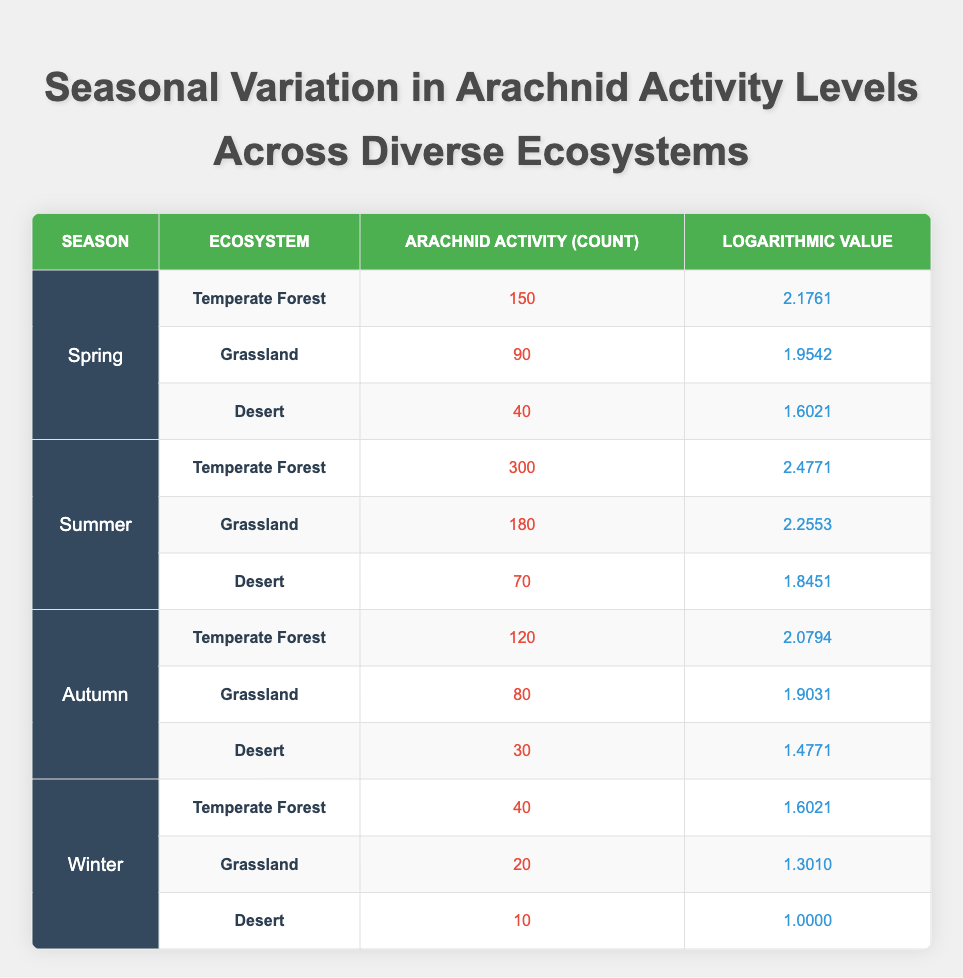What is the arachnid activity count in the Temperate Forest during Summer? The table indicates that in the Temperate Forest during the Summer season, the arachnid activity count is listed directly under that category, which shows a value of 300.
Answer: 300 Which ecosystem shows the highest arachnid activity count in Spring? To find this value, I look at all ecosystems under the Spring season. The counts are 150 for Temperate Forest, 90 for Grassland, and 40 for Desert. The highest among these is 150 for the Temperate Forest.
Answer: 150 What is the average arachnid activity count across all ecosystems during Autumn? To find the average in Autumn, I first sum the activity counts for Temperate Forest (120), Grassland (80), and Desert (30), which totals 230. Then, I divide this total by the number of ecosystems (3): 230/3 = 76.67, rounded to two decimal places.
Answer: 76.67 True or False: The arachnid activity count in the Grassland ecosystem is higher in Winter than in Autumn. In the Grassland during Winter, the count is 20, while in Autumn the count is 80. Since 20 is less than 80, the statement is false.
Answer: False Which season has the lowest overall arachnid activity count across all ecosystems? To determine this, I add the activity counts for each season: Spring (150+90+40=280), Summer (300+180+70=550), Autumn (120+80+30=230), and Winter (40+20+10=70). The total count for Winter is the lowest at 70.
Answer: Winter What is the difference in the logarithmic value of arachnid activity between Grassland in Summer and Grassland in Winter? For Grassland in Summer, the logarithmic value is 2.2553. In Winter, it is 1.3010. The difference is calculated as 2.2553 - 1.3010 = 0.9543.
Answer: 0.9543 Does the Desert ecosystem ever exceed an arachnid activity count of 50? By reviewing the counts for the Desert section across all seasons (40 in Spring, 70 in Summer, 30 in Autumn, and 10 in Winter), I see that the only season where it exceeds 50 is Summer, with a count of 70. Therefore, the statement is true.
Answer: True Which ecosystem in Summer has a logarithmic value closest to 2? In Summer, the logarithmic values for the ecosystems are: Temperate Forest 2.4771, Grassland 2.2553, and Desert 1.8451. The Grassland value of 2.2553 is the closest to 2.
Answer: Grassland 